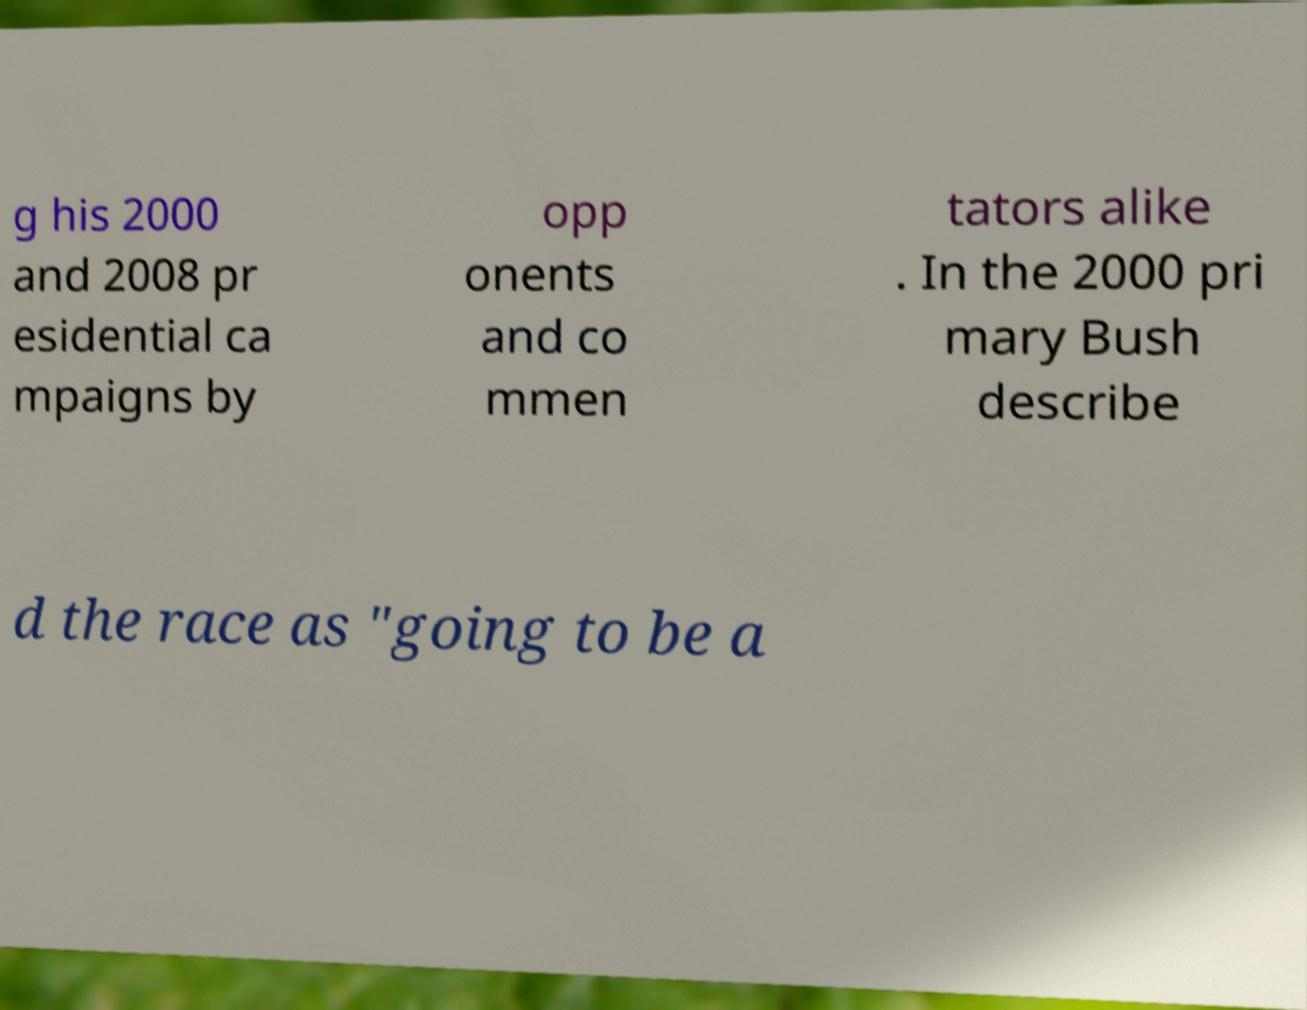What messages or text are displayed in this image? I need them in a readable, typed format. g his 2000 and 2008 pr esidential ca mpaigns by opp onents and co mmen tators alike . In the 2000 pri mary Bush describe d the race as "going to be a 